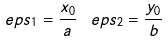<formula> <loc_0><loc_0><loc_500><loc_500>\ e p s _ { 1 } = \frac { x _ { 0 } } { a } \, \ e p s _ { 2 } = \frac { y _ { 0 } } { b }</formula> 